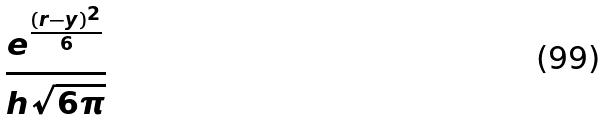<formula> <loc_0><loc_0><loc_500><loc_500>\frac { e ^ { \frac { ( r - y ) ^ { 2 } } { 6 } } } { h \sqrt { 6 \pi } }</formula> 